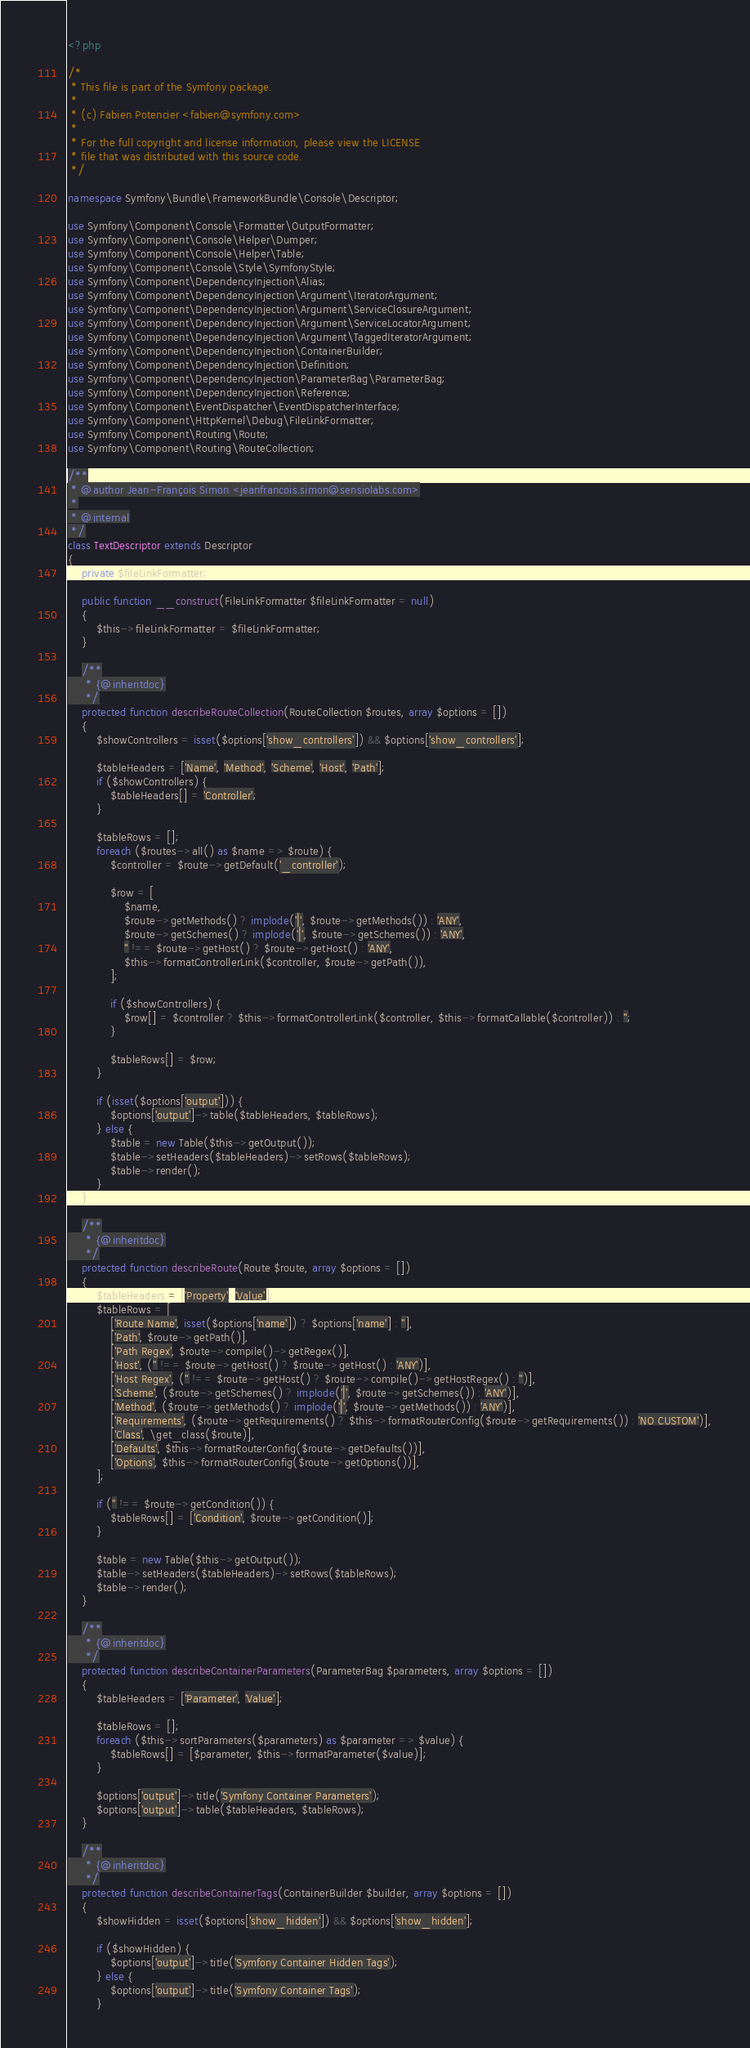<code> <loc_0><loc_0><loc_500><loc_500><_PHP_><?php

/*
 * This file is part of the Symfony package.
 *
 * (c) Fabien Potencier <fabien@symfony.com>
 *
 * For the full copyright and license information, please view the LICENSE
 * file that was distributed with this source code.
 */

namespace Symfony\Bundle\FrameworkBundle\Console\Descriptor;

use Symfony\Component\Console\Formatter\OutputFormatter;
use Symfony\Component\Console\Helper\Dumper;
use Symfony\Component\Console\Helper\Table;
use Symfony\Component\Console\Style\SymfonyStyle;
use Symfony\Component\DependencyInjection\Alias;
use Symfony\Component\DependencyInjection\Argument\IteratorArgument;
use Symfony\Component\DependencyInjection\Argument\ServiceClosureArgument;
use Symfony\Component\DependencyInjection\Argument\ServiceLocatorArgument;
use Symfony\Component\DependencyInjection\Argument\TaggedIteratorArgument;
use Symfony\Component\DependencyInjection\ContainerBuilder;
use Symfony\Component\DependencyInjection\Definition;
use Symfony\Component\DependencyInjection\ParameterBag\ParameterBag;
use Symfony\Component\DependencyInjection\Reference;
use Symfony\Component\EventDispatcher\EventDispatcherInterface;
use Symfony\Component\HttpKernel\Debug\FileLinkFormatter;
use Symfony\Component\Routing\Route;
use Symfony\Component\Routing\RouteCollection;

/**
 * @author Jean-François Simon <jeanfrancois.simon@sensiolabs.com>
 *
 * @internal
 */
class TextDescriptor extends Descriptor
{
    private $fileLinkFormatter;

    public function __construct(FileLinkFormatter $fileLinkFormatter = null)
    {
        $this->fileLinkFormatter = $fileLinkFormatter;
    }

    /**
     * {@inheritdoc}
     */
    protected function describeRouteCollection(RouteCollection $routes, array $options = [])
    {
        $showControllers = isset($options['show_controllers']) && $options['show_controllers'];

        $tableHeaders = ['Name', 'Method', 'Scheme', 'Host', 'Path'];
        if ($showControllers) {
            $tableHeaders[] = 'Controller';
        }

        $tableRows = [];
        foreach ($routes->all() as $name => $route) {
            $controller = $route->getDefault('_controller');

            $row = [
                $name,
                $route->getMethods() ? implode('|', $route->getMethods()) : 'ANY',
                $route->getSchemes() ? implode('|', $route->getSchemes()) : 'ANY',
                '' !== $route->getHost() ? $route->getHost() : 'ANY',
                $this->formatControllerLink($controller, $route->getPath()),
            ];

            if ($showControllers) {
                $row[] = $controller ? $this->formatControllerLink($controller, $this->formatCallable($controller)) : '';
            }

            $tableRows[] = $row;
        }

        if (isset($options['output'])) {
            $options['output']->table($tableHeaders, $tableRows);
        } else {
            $table = new Table($this->getOutput());
            $table->setHeaders($tableHeaders)->setRows($tableRows);
            $table->render();
        }
    }

    /**
     * {@inheritdoc}
     */
    protected function describeRoute(Route $route, array $options = [])
    {
        $tableHeaders = ['Property', 'Value'];
        $tableRows = [
            ['Route Name', isset($options['name']) ? $options['name'] : ''],
            ['Path', $route->getPath()],
            ['Path Regex', $route->compile()->getRegex()],
            ['Host', ('' !== $route->getHost() ? $route->getHost() : 'ANY')],
            ['Host Regex', ('' !== $route->getHost() ? $route->compile()->getHostRegex() : '')],
            ['Scheme', ($route->getSchemes() ? implode('|', $route->getSchemes()) : 'ANY')],
            ['Method', ($route->getMethods() ? implode('|', $route->getMethods()) : 'ANY')],
            ['Requirements', ($route->getRequirements() ? $this->formatRouterConfig($route->getRequirements()) : 'NO CUSTOM')],
            ['Class', \get_class($route)],
            ['Defaults', $this->formatRouterConfig($route->getDefaults())],
            ['Options', $this->formatRouterConfig($route->getOptions())],
        ];

        if ('' !== $route->getCondition()) {
            $tableRows[] = ['Condition', $route->getCondition()];
        }

        $table = new Table($this->getOutput());
        $table->setHeaders($tableHeaders)->setRows($tableRows);
        $table->render();
    }

    /**
     * {@inheritdoc}
     */
    protected function describeContainerParameters(ParameterBag $parameters, array $options = [])
    {
        $tableHeaders = ['Parameter', 'Value'];

        $tableRows = [];
        foreach ($this->sortParameters($parameters) as $parameter => $value) {
            $tableRows[] = [$parameter, $this->formatParameter($value)];
        }

        $options['output']->title('Symfony Container Parameters');
        $options['output']->table($tableHeaders, $tableRows);
    }

    /**
     * {@inheritdoc}
     */
    protected function describeContainerTags(ContainerBuilder $builder, array $options = [])
    {
        $showHidden = isset($options['show_hidden']) && $options['show_hidden'];

        if ($showHidden) {
            $options['output']->title('Symfony Container Hidden Tags');
        } else {
            $options['output']->title('Symfony Container Tags');
        }
</code> 